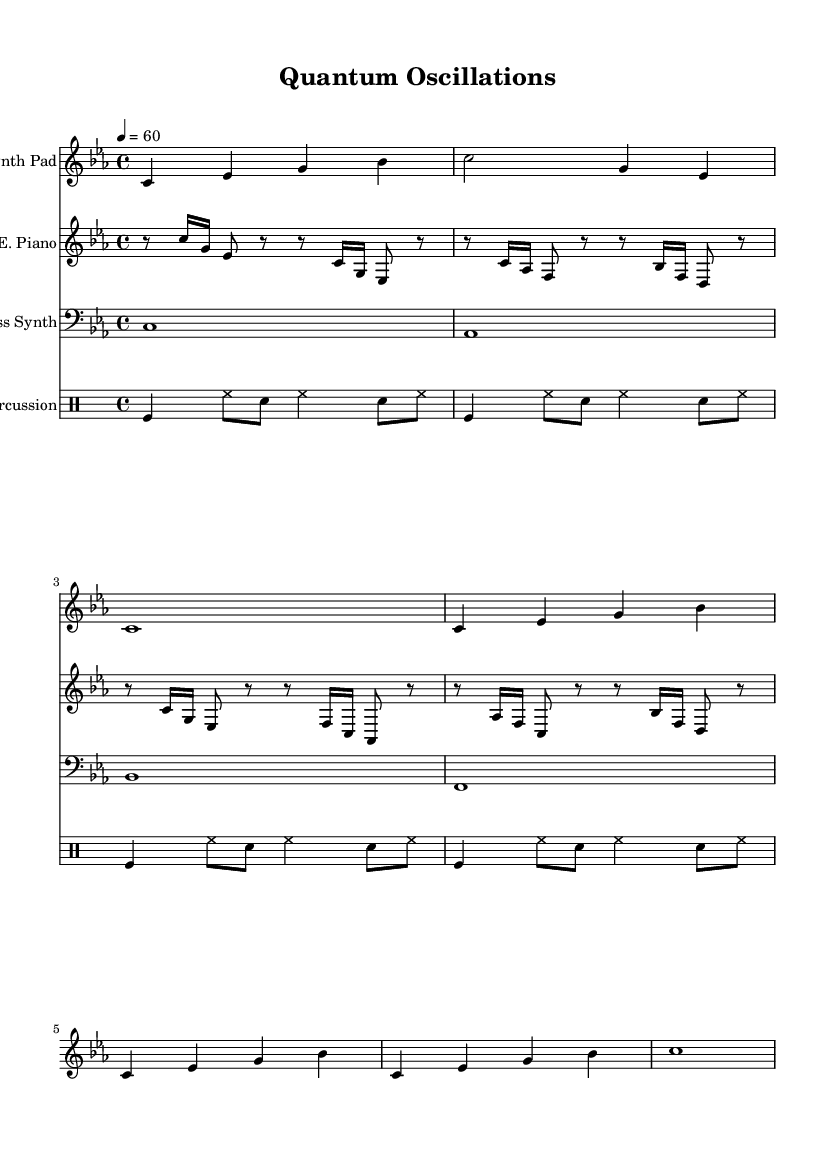What is the key signature of this music? The key signature shows three flats, which indicates the piece is in C minor.
Answer: C minor What is the time signature of this piece? The time signature indicated in the sheet music is 4/4, meaning there are four beats per measure, and a quarter note gets one beat.
Answer: 4/4 What is the tempo marking for the piece? The tempo marking is indicated as "4 = 60," meaning that there should be 60 quarter note beats per minute.
Answer: 60 How many measures are in the synth pad section? Upon examining the synth pad section, it can be noted that there are a total of six measures.
Answer: 6 Which instrument has the longest note value in the piece? By analyzing the note values in the different instruments, the bass synth plays whole notes that last for a measure, which is the longest note value in this piece.
Answer: Bass Synth What is the rhythmic pattern used in the percussion section? The percussion section uses a repeating pattern consisting of toms, hi-hat, and snare. This structure is consistent throughout the repeated measures, creating a driving rhythm typical of ambient music.
Answer: Toms, hi-hat, snare Which section of the score contains the most frequent repetition? The synth pad section includes a repeated pattern that unfolds three times, which is more repetitive compared to the other instrument sections.
Answer: Synth Pad 